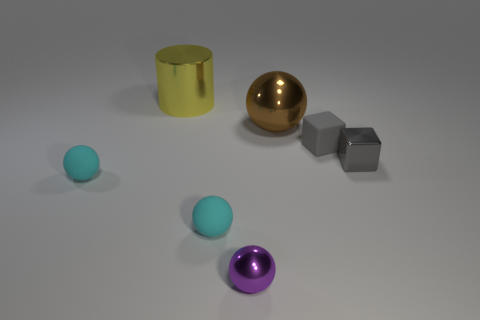There is a matte cube; is its color the same as the cube that is in front of the gray matte block?
Your answer should be compact. Yes. Is there anything else that is the same size as the gray rubber block?
Keep it short and to the point. Yes. Are there fewer big things that are to the left of the large metal sphere than purple metallic objects behind the large yellow metallic thing?
Offer a very short reply. No. How many tiny matte blocks are in front of the metallic sphere that is left of the big brown shiny sphere?
Give a very brief answer. 0. Is there a yellow metal thing?
Your response must be concise. Yes. Are there any big green cylinders made of the same material as the purple object?
Provide a succinct answer. No. Are there more gray rubber blocks that are in front of the small metallic cube than tiny cyan spheres on the left side of the yellow cylinder?
Your answer should be very brief. No. Does the brown thing have the same size as the yellow cylinder?
Make the answer very short. Yes. The large metal object that is left of the big thing on the right side of the small purple thing is what color?
Offer a very short reply. Yellow. The matte cube has what color?
Give a very brief answer. Gray. 